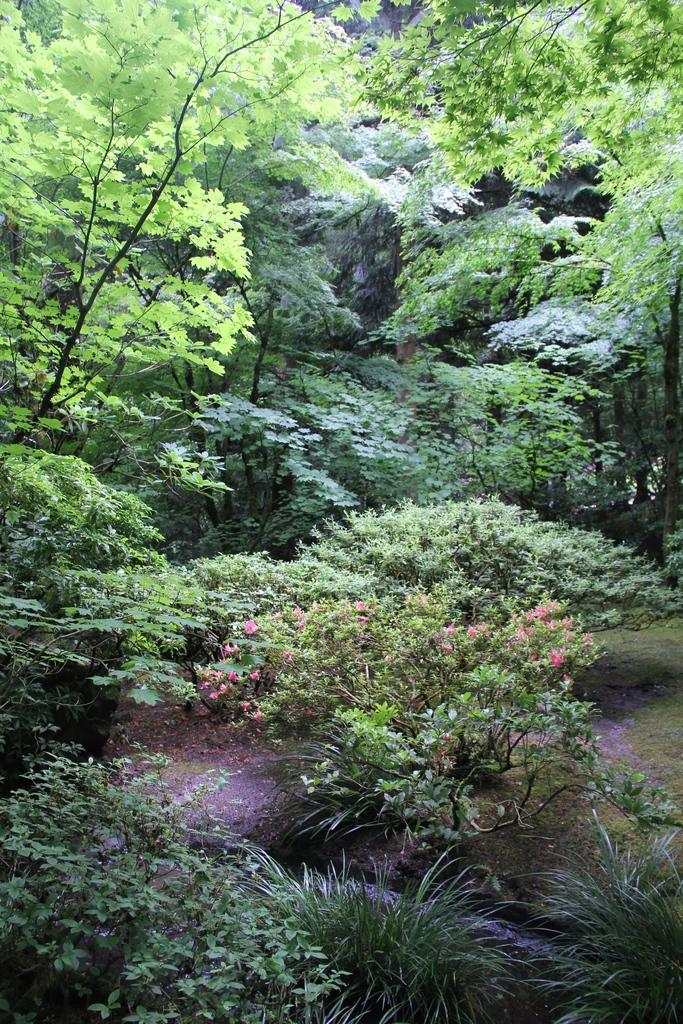What type of vegetation is present in the image? There are many trees and plants in the image. Can you describe the flowers on the plants? The flowers on the plants are pink in color. Where is the brother's cemetery located in the image? There is no mention of a brother or a cemetery in the image. 